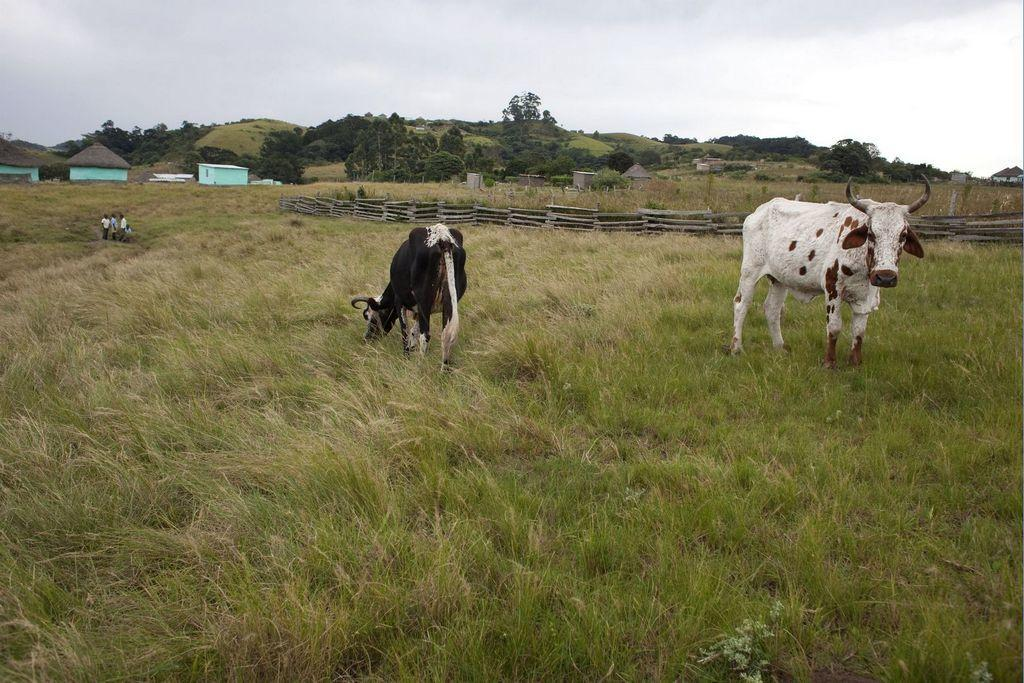What type of vegetation can be seen in the image? There is grass in the image. What animals are present in the image? There are cows in the image. What structures can be seen in the image? There are fencehouses in the image. Who or what else is present in the image? There are people in the image. What else can be seen in the background of the image? There are trees in the image. What is visible above the scene in the image? The sky is visible in the image. How many pins are holding the cows in place in the image? There are no pins present in the image; the cows are not held in place by any visible means. What type of muscle is being exercised by the people in the image? There is no specific muscle being exercised by the people in the image, as their activities are not described in the provided facts. 